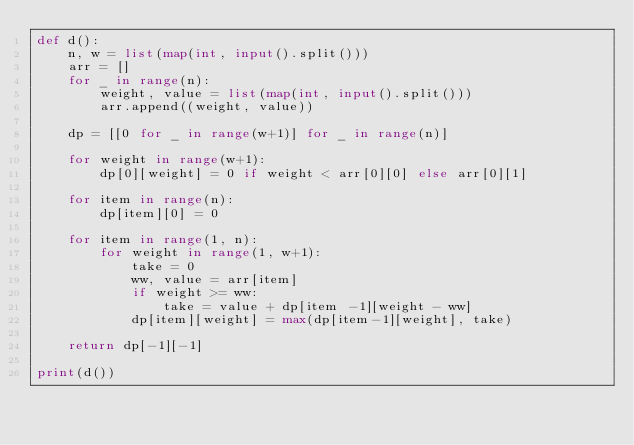<code> <loc_0><loc_0><loc_500><loc_500><_Python_>def d():
    n, w = list(map(int, input().split()))
    arr = []
    for _ in range(n):
        weight, value = list(map(int, input().split()))
        arr.append((weight, value))

    dp = [[0 for _ in range(w+1)] for _ in range(n)]

    for weight in range(w+1):
        dp[0][weight] = 0 if weight < arr[0][0] else arr[0][1]

    for item in range(n):
        dp[item][0] = 0

    for item in range(1, n):
        for weight in range(1, w+1):
            take = 0
            ww, value = arr[item]
            if weight >= ww:
                take = value + dp[item -1][weight - ww]
            dp[item][weight] = max(dp[item-1][weight], take)
            
    return dp[-1][-1]

print(d())</code> 